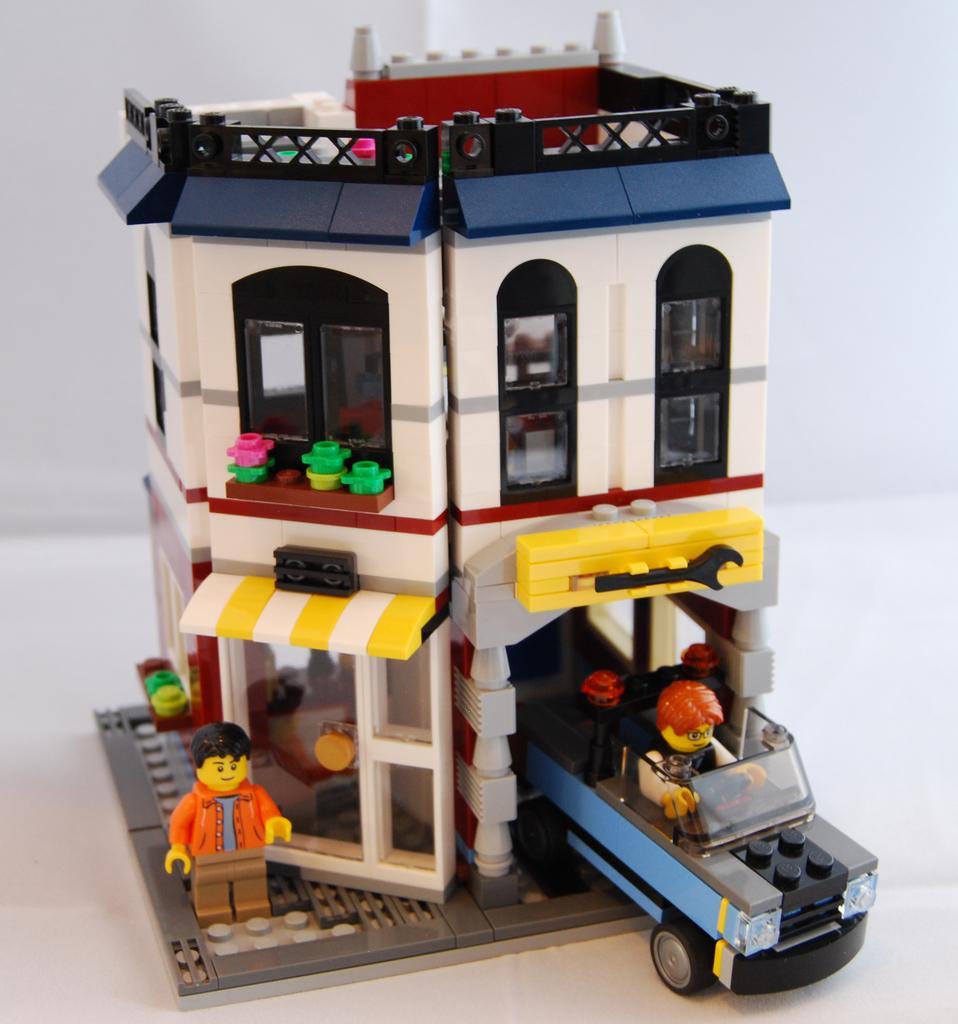Could you give a brief overview of what you see in this image? In this image it looks like a lego. 